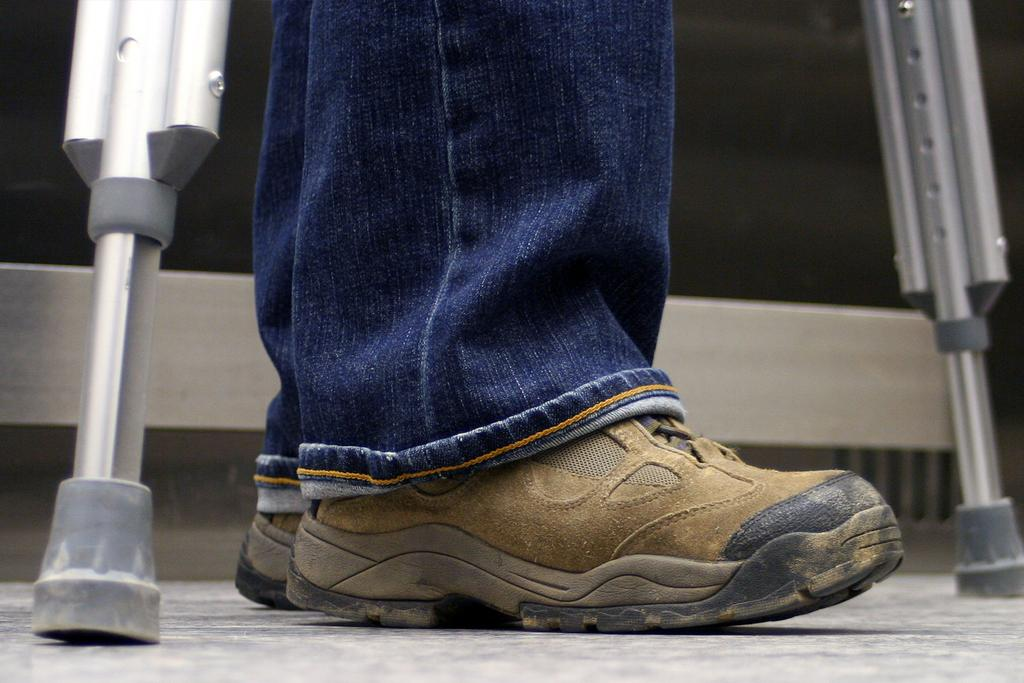What part of a person can be seen in the image? There are legs of a person in the image. What can be seen in the background of the image? There are stands and a wall in the background of the image. What type of coat is the person wearing in the image? There is no coat visible in the image, as only the legs of a person are shown. 